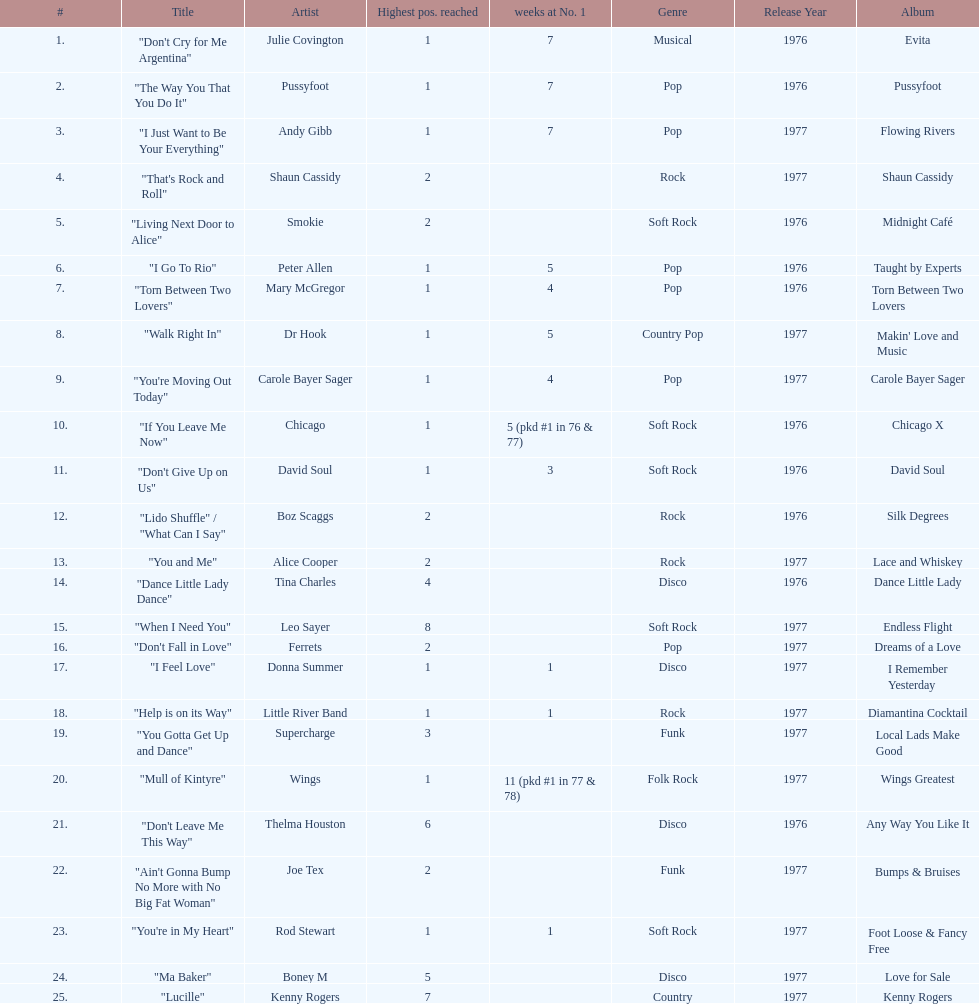How many songs in the table only reached position number 2? 6. 